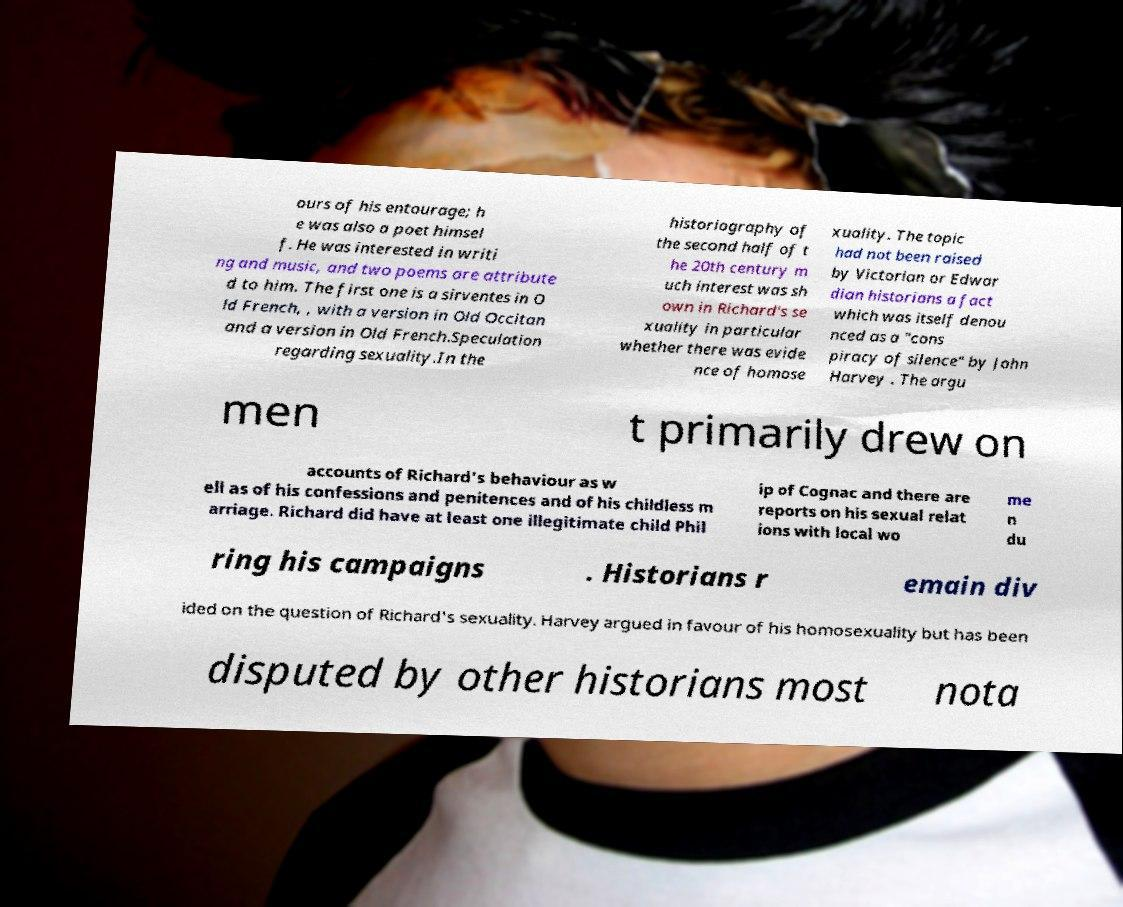What messages or text are displayed in this image? I need them in a readable, typed format. ours of his entourage; h e was also a poet himsel f. He was interested in writi ng and music, and two poems are attribute d to him. The first one is a sirventes in O ld French, , with a version in Old Occitan and a version in Old French.Speculation regarding sexuality.In the historiography of the second half of t he 20th century m uch interest was sh own in Richard's se xuality in particular whether there was evide nce of homose xuality. The topic had not been raised by Victorian or Edwar dian historians a fact which was itself denou nced as a "cons piracy of silence" by John Harvey . The argu men t primarily drew on accounts of Richard's behaviour as w ell as of his confessions and penitences and of his childless m arriage. Richard did have at least one illegitimate child Phil ip of Cognac and there are reports on his sexual relat ions with local wo me n du ring his campaigns . Historians r emain div ided on the question of Richard's sexuality. Harvey argued in favour of his homosexuality but has been disputed by other historians most nota 